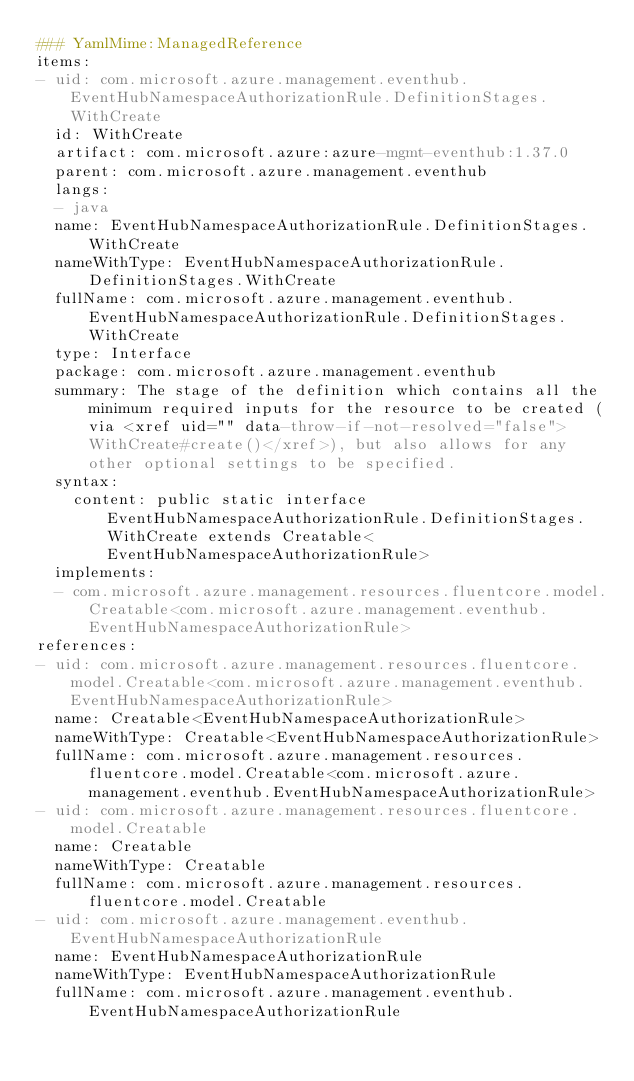<code> <loc_0><loc_0><loc_500><loc_500><_YAML_>### YamlMime:ManagedReference
items:
- uid: com.microsoft.azure.management.eventhub.EventHubNamespaceAuthorizationRule.DefinitionStages.WithCreate
  id: WithCreate
  artifact: com.microsoft.azure:azure-mgmt-eventhub:1.37.0
  parent: com.microsoft.azure.management.eventhub
  langs:
  - java
  name: EventHubNamespaceAuthorizationRule.DefinitionStages.WithCreate
  nameWithType: EventHubNamespaceAuthorizationRule.DefinitionStages.WithCreate
  fullName: com.microsoft.azure.management.eventhub.EventHubNamespaceAuthorizationRule.DefinitionStages.WithCreate
  type: Interface
  package: com.microsoft.azure.management.eventhub
  summary: The stage of the definition which contains all the minimum required inputs for the resource to be created (via <xref uid="" data-throw-if-not-resolved="false">WithCreate#create()</xref>), but also allows for any other optional settings to be specified.
  syntax:
    content: public static interface EventHubNamespaceAuthorizationRule.DefinitionStages.WithCreate extends Creatable<EventHubNamespaceAuthorizationRule>
  implements:
  - com.microsoft.azure.management.resources.fluentcore.model.Creatable<com.microsoft.azure.management.eventhub.EventHubNamespaceAuthorizationRule>
references:
- uid: com.microsoft.azure.management.resources.fluentcore.model.Creatable<com.microsoft.azure.management.eventhub.EventHubNamespaceAuthorizationRule>
  name: Creatable<EventHubNamespaceAuthorizationRule>
  nameWithType: Creatable<EventHubNamespaceAuthorizationRule>
  fullName: com.microsoft.azure.management.resources.fluentcore.model.Creatable<com.microsoft.azure.management.eventhub.EventHubNamespaceAuthorizationRule>
- uid: com.microsoft.azure.management.resources.fluentcore.model.Creatable
  name: Creatable
  nameWithType: Creatable
  fullName: com.microsoft.azure.management.resources.fluentcore.model.Creatable
- uid: com.microsoft.azure.management.eventhub.EventHubNamespaceAuthorizationRule
  name: EventHubNamespaceAuthorizationRule
  nameWithType: EventHubNamespaceAuthorizationRule
  fullName: com.microsoft.azure.management.eventhub.EventHubNamespaceAuthorizationRule
</code> 